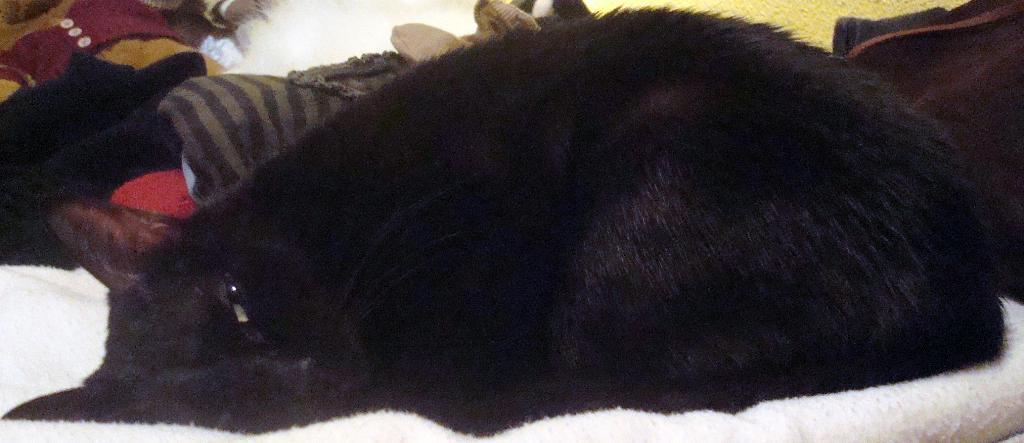What is the main subject of the image? There is a cat in the center of the image. What color is the cat? The cat is black in color. What is the cat lying on? The cat is lying on a white cloth. What can be seen in the background of the image? There are clothes visible in the background of the image. How many crows are sitting on the chair in the image? There is no chair or crow present in the image; it features a black cat lying on a white cloth. 